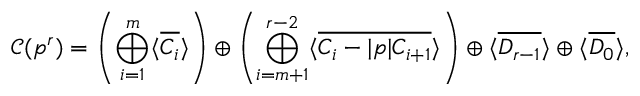Convert formula to latex. <formula><loc_0><loc_0><loc_500><loc_500>\mathcal { C } ( \mathfrak { p } ^ { r } ) = \left ( \bigoplus _ { i = 1 } ^ { m } \langle \overline { { C _ { i } } } \rangle \right ) \oplus \left ( \bigoplus _ { i = m + 1 } ^ { r - 2 } \langle \overline { { C _ { i } - | \mathfrak { p } | C _ { i + 1 } } } \rangle \right ) \oplus \langle \overline { { D _ { r - 1 } } } \rangle \oplus \langle \overline { { D _ { 0 } } } \rangle ,</formula> 